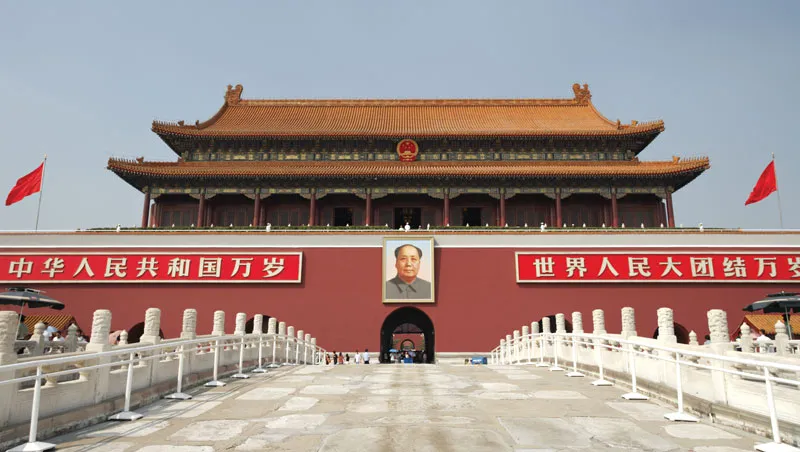What details can you tell me about the architecture seen in this image? The architecture of Tiananmen Gate is a prime example of traditional Chinese architectural style, characterized by its large wooden structures and sweeping roofs covered with golden glazed tiles. The symmetry of the building is a crucial element in Chinese architecture, symbolizing balance and harmony. Intricate designs, including rafter details under the eaves and large red doors, emphasize its grandeur and the ceremonial importance of the gate historically used for imperial parades. 